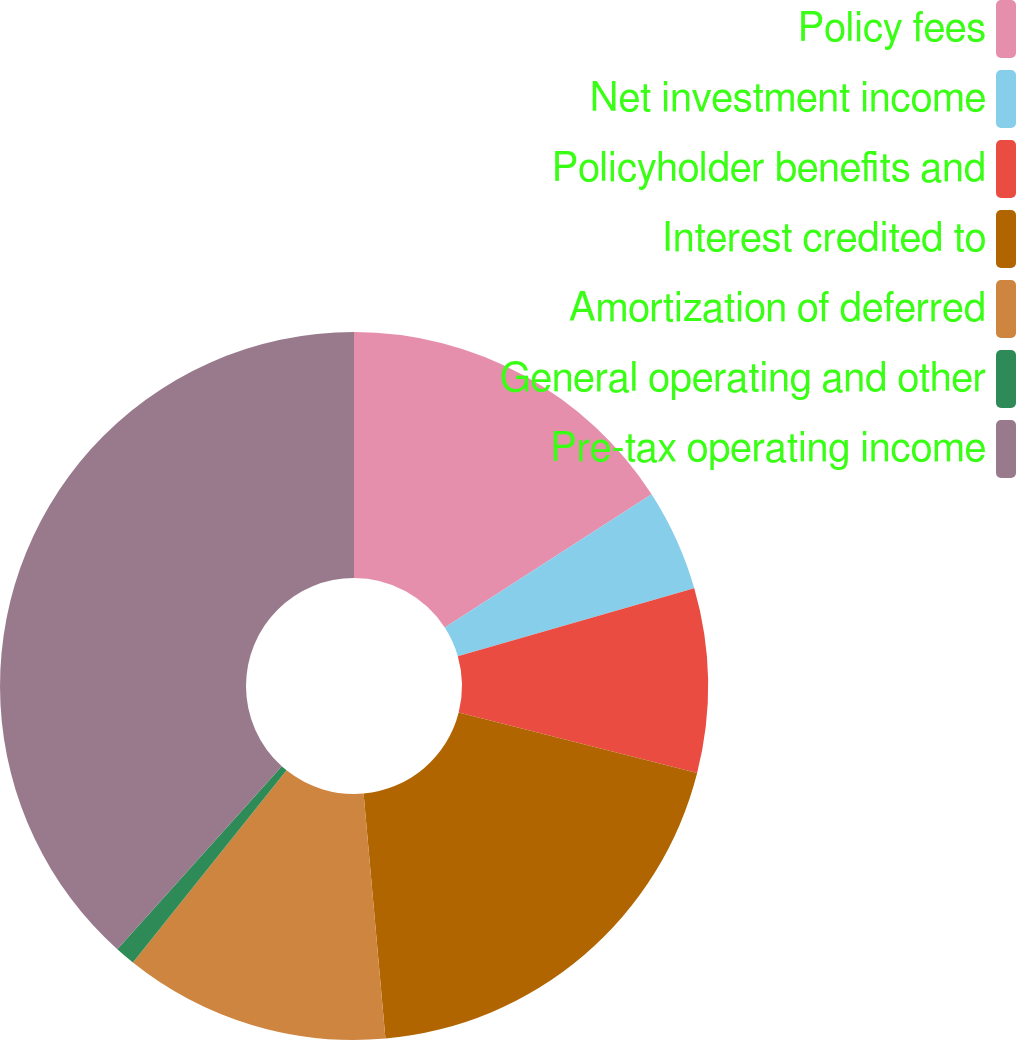Convert chart. <chart><loc_0><loc_0><loc_500><loc_500><pie_chart><fcel>Policy fees<fcel>Net investment income<fcel>Policyholder benefits and<fcel>Interest credited to<fcel>Amortization of deferred<fcel>General operating and other<fcel>Pre-tax operating income<nl><fcel>15.89%<fcel>4.66%<fcel>8.4%<fcel>19.63%<fcel>12.15%<fcel>0.92%<fcel>38.34%<nl></chart> 